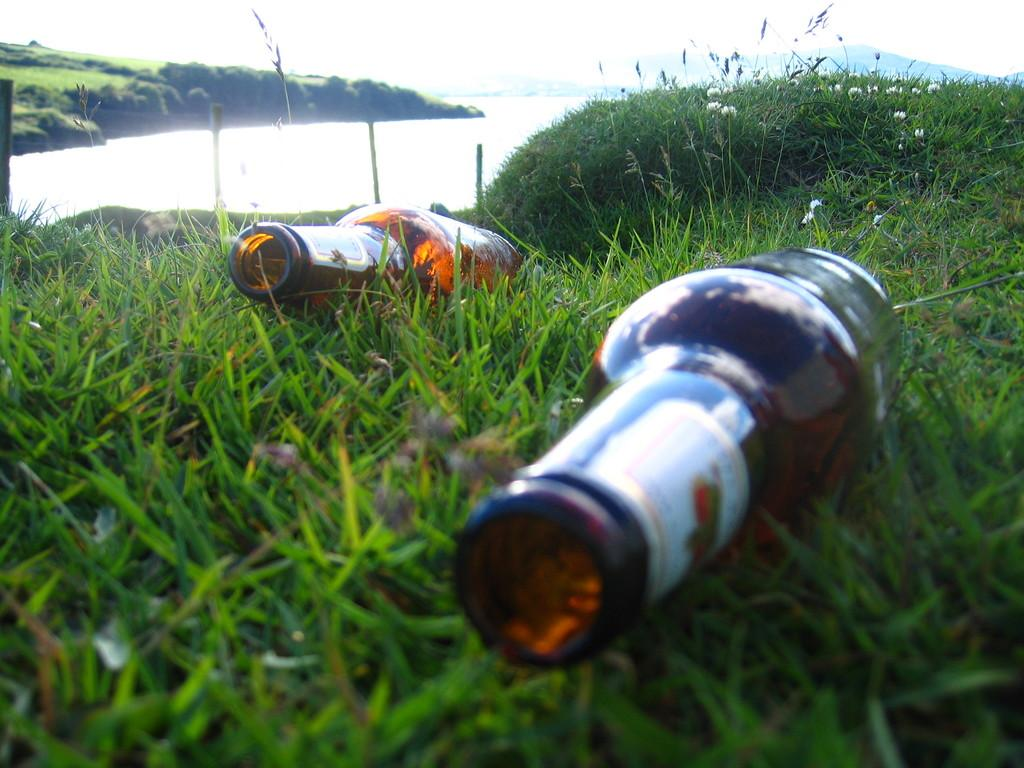How many glass bottles are in the image? There are two glass bottles in the image. Where are the glass bottles located? The glass bottles are on grassy land. What can be seen in the background of the image? Water and the sky are visible in the background of the image. What type of cabbage is growing in the hole near the glass bottles? There is no cabbage or hole present in the image; it only features two glass bottles on grassy land with water and the sky visible in the background. 